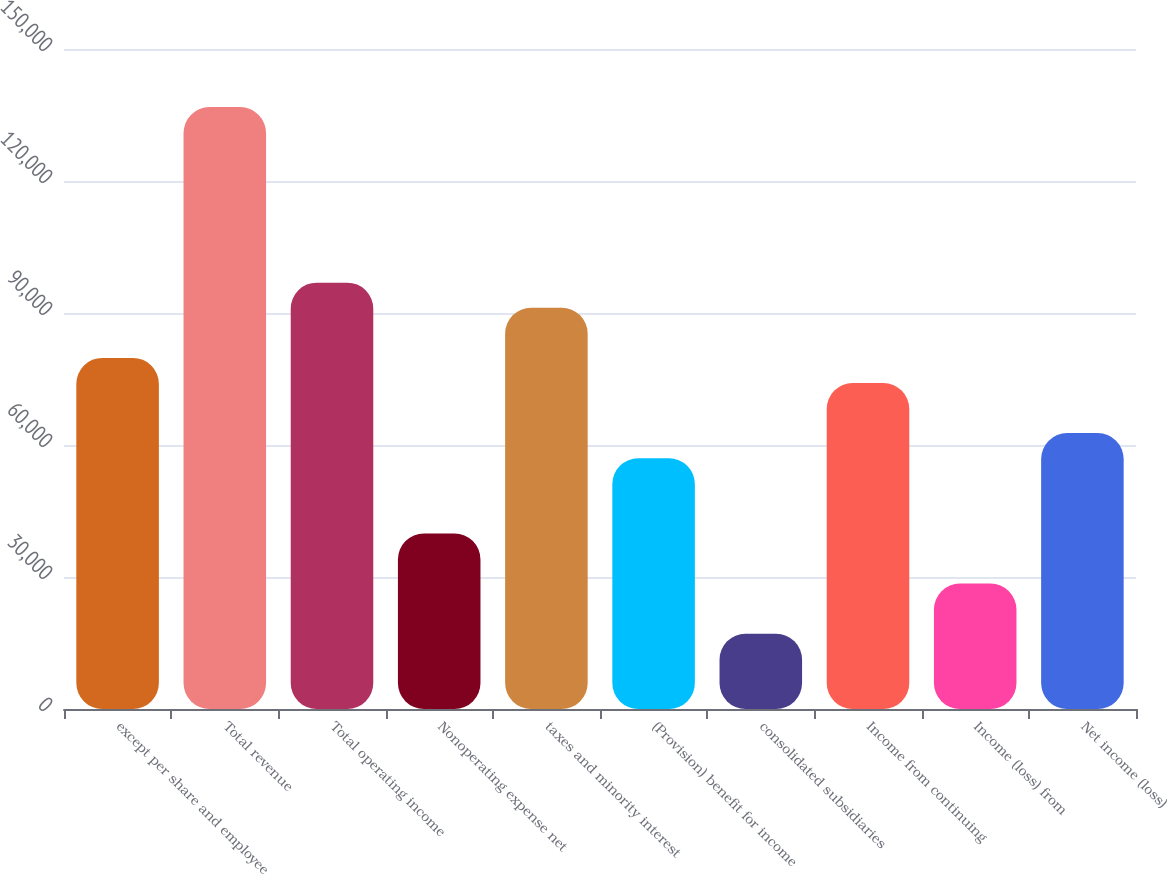<chart> <loc_0><loc_0><loc_500><loc_500><bar_chart><fcel>except per share and employee<fcel>Total revenue<fcel>Total operating income<fcel>Nonoperating expense net<fcel>taxes and minority interest<fcel>(Provision) benefit for income<fcel>consolidated subsidiaries<fcel>Income from continuing<fcel>Income (loss) from<fcel>Net income (loss)<nl><fcel>79799.8<fcel>136799<fcel>96899.7<fcel>39900.1<fcel>91199.7<fcel>57000<fcel>17100.2<fcel>74099.8<fcel>28500.2<fcel>62699.9<nl></chart> 